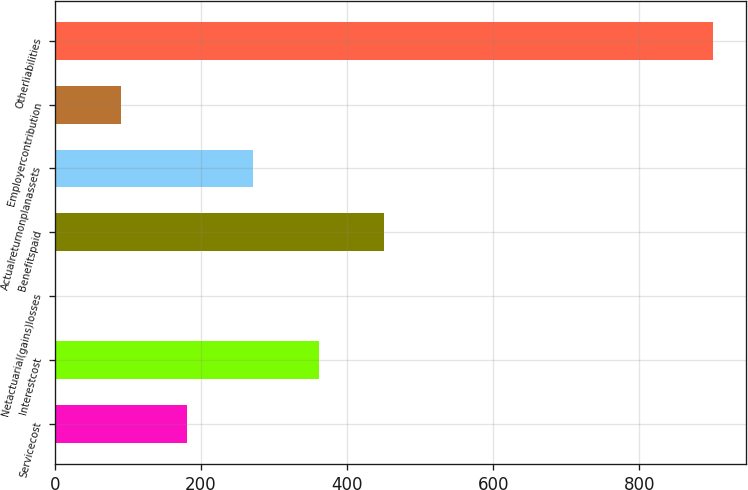<chart> <loc_0><loc_0><loc_500><loc_500><bar_chart><fcel>Servicecost<fcel>Interestcost<fcel>Netactuarial(gains)losses<fcel>Benefitspaid<fcel>Actualreturnonplanassets<fcel>Employercontribution<fcel>Otherliabilities<nl><fcel>181<fcel>361<fcel>1<fcel>451<fcel>271<fcel>91<fcel>901<nl></chart> 